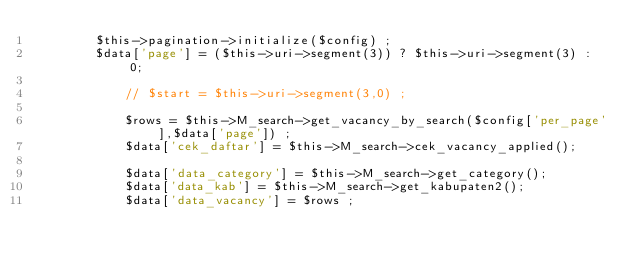<code> <loc_0><loc_0><loc_500><loc_500><_PHP_>				$this->pagination->initialize($config) ;
				$data['page'] = ($this->uri->segment(3)) ? $this->uri->segment(3) : 0;

        		// $start = $this->uri->segment(3,0) ;

        		$rows = $this->M_search->get_vacancy_by_search($config['per_page'],$data['page']) ;
	   		    $data['cek_daftar'] = $this->M_search->cek_vacancy_applied();

	   		    $data['data_category'] = $this->M_search->get_category();    
	   		    $data['data_kab'] = $this->M_search->get_kabupaten2();
	   		    $data['data_vacancy'] = $rows ;   </code> 